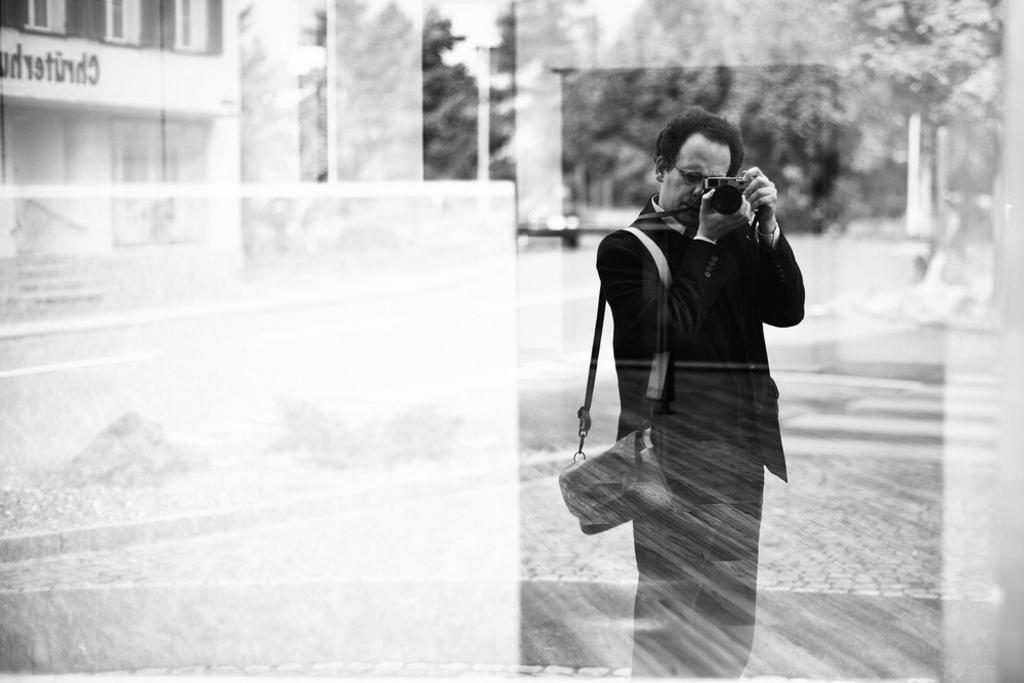What is the main subject in the front of the image? There is a man standing in the front of the image. What is the man wearing? The man is wearing a black suit. What is the man doing in the image? The man is taking photos in the glass. What can be seen in the background of the image? There is a building and trees in the background of the image. How many bikes are parked next to the man in the image? There are no bikes present in the image. Who is the owner of the trees in the background? The concept of ownership for trees in a public space is not applicable in this context, as trees are part of the natural environment. 